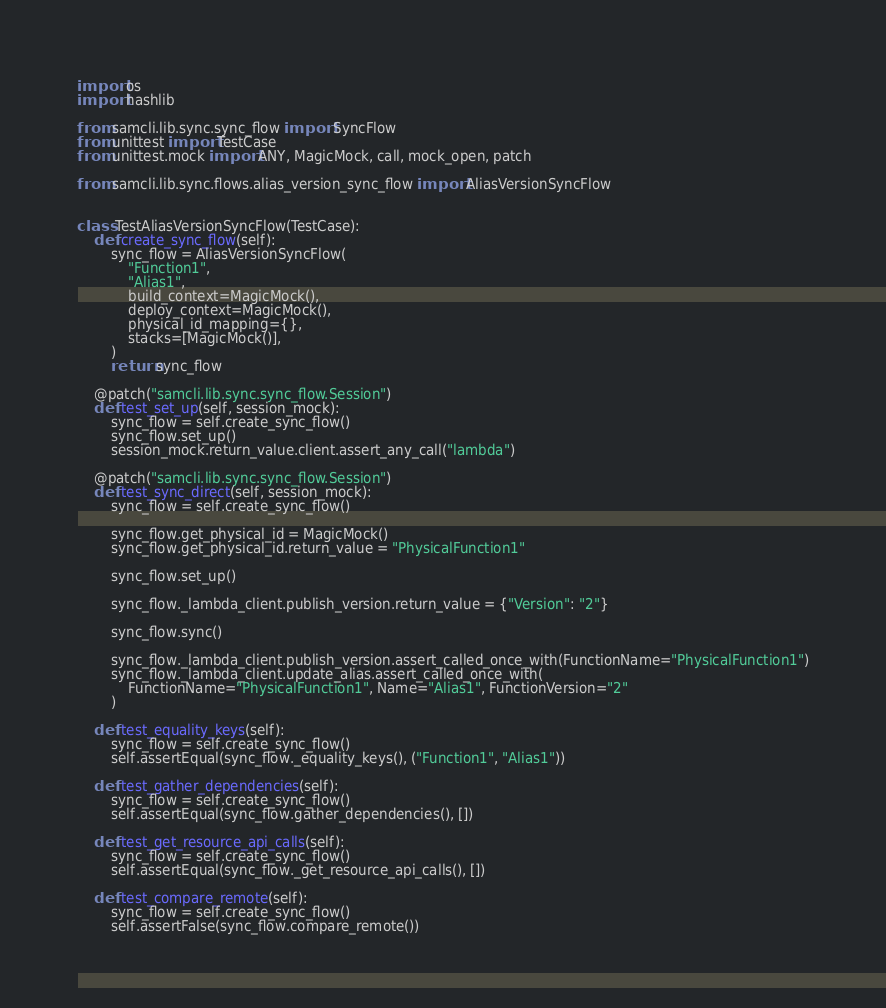Convert code to text. <code><loc_0><loc_0><loc_500><loc_500><_Python_>import os
import hashlib

from samcli.lib.sync.sync_flow import SyncFlow
from unittest import TestCase
from unittest.mock import ANY, MagicMock, call, mock_open, patch

from samcli.lib.sync.flows.alias_version_sync_flow import AliasVersionSyncFlow


class TestAliasVersionSyncFlow(TestCase):
    def create_sync_flow(self):
        sync_flow = AliasVersionSyncFlow(
            "Function1",
            "Alias1",
            build_context=MagicMock(),
            deploy_context=MagicMock(),
            physical_id_mapping={},
            stacks=[MagicMock()],
        )
        return sync_flow

    @patch("samcli.lib.sync.sync_flow.Session")
    def test_set_up(self, session_mock):
        sync_flow = self.create_sync_flow()
        sync_flow.set_up()
        session_mock.return_value.client.assert_any_call("lambda")

    @patch("samcli.lib.sync.sync_flow.Session")
    def test_sync_direct(self, session_mock):
        sync_flow = self.create_sync_flow()

        sync_flow.get_physical_id = MagicMock()
        sync_flow.get_physical_id.return_value = "PhysicalFunction1"

        sync_flow.set_up()

        sync_flow._lambda_client.publish_version.return_value = {"Version": "2"}

        sync_flow.sync()

        sync_flow._lambda_client.publish_version.assert_called_once_with(FunctionName="PhysicalFunction1")
        sync_flow._lambda_client.update_alias.assert_called_once_with(
            FunctionName="PhysicalFunction1", Name="Alias1", FunctionVersion="2"
        )

    def test_equality_keys(self):
        sync_flow = self.create_sync_flow()
        self.assertEqual(sync_flow._equality_keys(), ("Function1", "Alias1"))

    def test_gather_dependencies(self):
        sync_flow = self.create_sync_flow()
        self.assertEqual(sync_flow.gather_dependencies(), [])

    def test_get_resource_api_calls(self):
        sync_flow = self.create_sync_flow()
        self.assertEqual(sync_flow._get_resource_api_calls(), [])

    def test_compare_remote(self):
        sync_flow = self.create_sync_flow()
        self.assertFalse(sync_flow.compare_remote())
</code> 